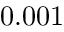Convert formula to latex. <formula><loc_0><loc_0><loc_500><loc_500>0 . 0 0 1</formula> 